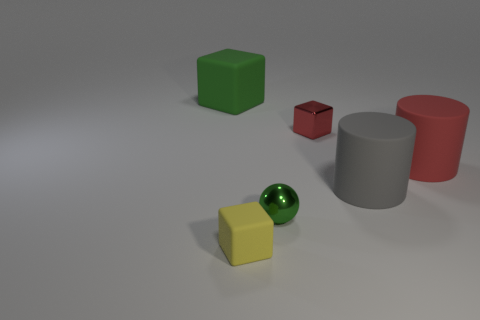Add 4 tiny rubber blocks. How many objects exist? 10 Subtract all red cylinders. How many cylinders are left? 1 Subtract all red cubes. How many cubes are left? 2 Subtract 1 green spheres. How many objects are left? 5 Subtract all cylinders. How many objects are left? 4 Subtract 1 balls. How many balls are left? 0 Subtract all blue blocks. Subtract all blue spheres. How many blocks are left? 3 Subtract all yellow cubes. How many gray cylinders are left? 1 Subtract all large purple cylinders. Subtract all cylinders. How many objects are left? 4 Add 2 tiny red metallic things. How many tiny red metallic things are left? 3 